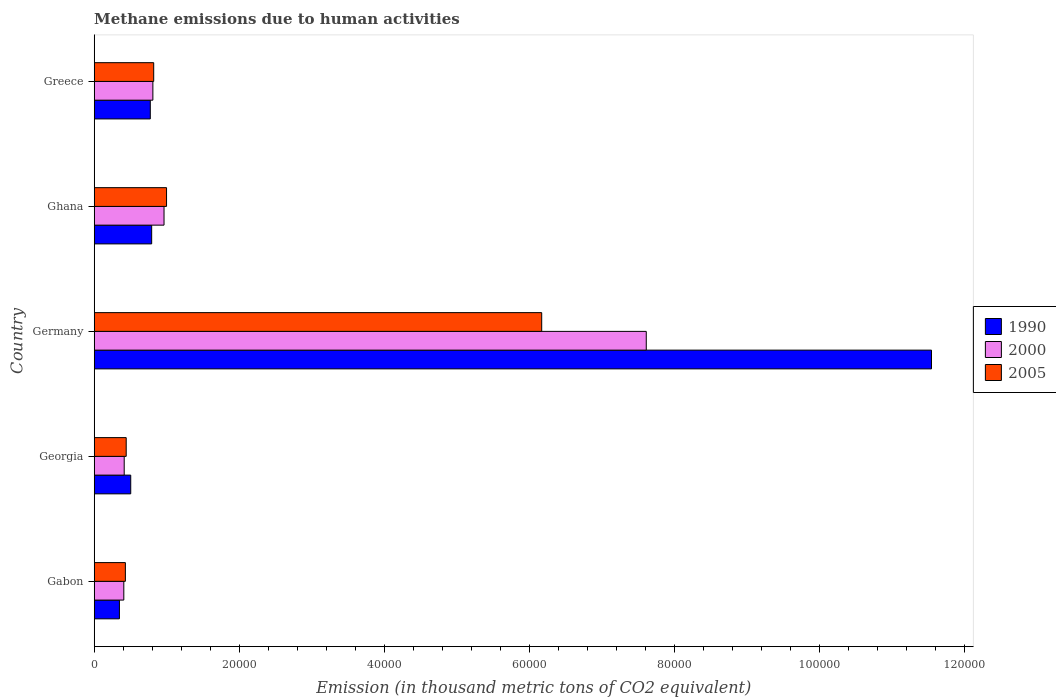How many different coloured bars are there?
Provide a succinct answer. 3. Are the number of bars per tick equal to the number of legend labels?
Keep it short and to the point. Yes. Are the number of bars on each tick of the Y-axis equal?
Provide a short and direct response. Yes. What is the label of the 4th group of bars from the top?
Make the answer very short. Georgia. What is the amount of methane emitted in 1990 in Greece?
Provide a short and direct response. 7734.1. Across all countries, what is the maximum amount of methane emitted in 1990?
Your response must be concise. 1.15e+05. Across all countries, what is the minimum amount of methane emitted in 2000?
Your answer should be very brief. 4082.1. In which country was the amount of methane emitted in 2005 minimum?
Keep it short and to the point. Gabon. What is the total amount of methane emitted in 2005 in the graph?
Your response must be concise. 8.86e+04. What is the difference between the amount of methane emitted in 1990 in Gabon and that in Ghana?
Give a very brief answer. -4446.2. What is the difference between the amount of methane emitted in 2000 in Ghana and the amount of methane emitted in 2005 in Georgia?
Your answer should be very brief. 5214.7. What is the average amount of methane emitted in 1990 per country?
Provide a short and direct response. 2.79e+04. What is the difference between the amount of methane emitted in 1990 and amount of methane emitted in 2000 in Greece?
Offer a very short reply. -355.1. What is the ratio of the amount of methane emitted in 2000 in Gabon to that in Ghana?
Ensure brevity in your answer.  0.42. Is the amount of methane emitted in 1990 in Gabon less than that in Ghana?
Offer a terse response. Yes. Is the difference between the amount of methane emitted in 1990 in Germany and Ghana greater than the difference between the amount of methane emitted in 2000 in Germany and Ghana?
Give a very brief answer. Yes. What is the difference between the highest and the second highest amount of methane emitted in 2000?
Provide a succinct answer. 6.65e+04. What is the difference between the highest and the lowest amount of methane emitted in 1990?
Ensure brevity in your answer.  1.12e+05. What does the 2nd bar from the top in Germany represents?
Offer a terse response. 2000. How many countries are there in the graph?
Provide a succinct answer. 5. What is the difference between two consecutive major ticks on the X-axis?
Keep it short and to the point. 2.00e+04. Are the values on the major ticks of X-axis written in scientific E-notation?
Make the answer very short. No. Does the graph contain any zero values?
Keep it short and to the point. No. What is the title of the graph?
Give a very brief answer. Methane emissions due to human activities. What is the label or title of the X-axis?
Offer a very short reply. Emission (in thousand metric tons of CO2 equivalent). What is the Emission (in thousand metric tons of CO2 equivalent) of 1990 in Gabon?
Offer a terse response. 3478.5. What is the Emission (in thousand metric tons of CO2 equivalent) of 2000 in Gabon?
Your response must be concise. 4082.1. What is the Emission (in thousand metric tons of CO2 equivalent) in 2005 in Gabon?
Provide a succinct answer. 4298.1. What is the Emission (in thousand metric tons of CO2 equivalent) of 1990 in Georgia?
Give a very brief answer. 5037. What is the Emission (in thousand metric tons of CO2 equivalent) of 2000 in Georgia?
Offer a very short reply. 4137.4. What is the Emission (in thousand metric tons of CO2 equivalent) of 2005 in Georgia?
Keep it short and to the point. 4413.2. What is the Emission (in thousand metric tons of CO2 equivalent) in 1990 in Germany?
Provide a short and direct response. 1.15e+05. What is the Emission (in thousand metric tons of CO2 equivalent) in 2000 in Germany?
Your response must be concise. 7.61e+04. What is the Emission (in thousand metric tons of CO2 equivalent) in 2005 in Germany?
Provide a succinct answer. 6.17e+04. What is the Emission (in thousand metric tons of CO2 equivalent) in 1990 in Ghana?
Your response must be concise. 7924.7. What is the Emission (in thousand metric tons of CO2 equivalent) of 2000 in Ghana?
Provide a short and direct response. 9627.9. What is the Emission (in thousand metric tons of CO2 equivalent) in 2005 in Ghana?
Provide a succinct answer. 9975.3. What is the Emission (in thousand metric tons of CO2 equivalent) of 1990 in Greece?
Make the answer very short. 7734.1. What is the Emission (in thousand metric tons of CO2 equivalent) in 2000 in Greece?
Ensure brevity in your answer.  8089.2. What is the Emission (in thousand metric tons of CO2 equivalent) of 2005 in Greece?
Your response must be concise. 8204.9. Across all countries, what is the maximum Emission (in thousand metric tons of CO2 equivalent) in 1990?
Provide a short and direct response. 1.15e+05. Across all countries, what is the maximum Emission (in thousand metric tons of CO2 equivalent) of 2000?
Your response must be concise. 7.61e+04. Across all countries, what is the maximum Emission (in thousand metric tons of CO2 equivalent) of 2005?
Offer a very short reply. 6.17e+04. Across all countries, what is the minimum Emission (in thousand metric tons of CO2 equivalent) in 1990?
Your answer should be very brief. 3478.5. Across all countries, what is the minimum Emission (in thousand metric tons of CO2 equivalent) of 2000?
Your response must be concise. 4082.1. Across all countries, what is the minimum Emission (in thousand metric tons of CO2 equivalent) in 2005?
Keep it short and to the point. 4298.1. What is the total Emission (in thousand metric tons of CO2 equivalent) of 1990 in the graph?
Offer a terse response. 1.40e+05. What is the total Emission (in thousand metric tons of CO2 equivalent) of 2000 in the graph?
Your response must be concise. 1.02e+05. What is the total Emission (in thousand metric tons of CO2 equivalent) of 2005 in the graph?
Give a very brief answer. 8.86e+04. What is the difference between the Emission (in thousand metric tons of CO2 equivalent) in 1990 in Gabon and that in Georgia?
Make the answer very short. -1558.5. What is the difference between the Emission (in thousand metric tons of CO2 equivalent) of 2000 in Gabon and that in Georgia?
Your answer should be very brief. -55.3. What is the difference between the Emission (in thousand metric tons of CO2 equivalent) in 2005 in Gabon and that in Georgia?
Give a very brief answer. -115.1. What is the difference between the Emission (in thousand metric tons of CO2 equivalent) in 1990 in Gabon and that in Germany?
Your answer should be very brief. -1.12e+05. What is the difference between the Emission (in thousand metric tons of CO2 equivalent) of 2000 in Gabon and that in Germany?
Your response must be concise. -7.20e+04. What is the difference between the Emission (in thousand metric tons of CO2 equivalent) of 2005 in Gabon and that in Germany?
Keep it short and to the point. -5.74e+04. What is the difference between the Emission (in thousand metric tons of CO2 equivalent) of 1990 in Gabon and that in Ghana?
Offer a terse response. -4446.2. What is the difference between the Emission (in thousand metric tons of CO2 equivalent) of 2000 in Gabon and that in Ghana?
Your answer should be very brief. -5545.8. What is the difference between the Emission (in thousand metric tons of CO2 equivalent) of 2005 in Gabon and that in Ghana?
Your answer should be very brief. -5677.2. What is the difference between the Emission (in thousand metric tons of CO2 equivalent) in 1990 in Gabon and that in Greece?
Your answer should be very brief. -4255.6. What is the difference between the Emission (in thousand metric tons of CO2 equivalent) of 2000 in Gabon and that in Greece?
Make the answer very short. -4007.1. What is the difference between the Emission (in thousand metric tons of CO2 equivalent) of 2005 in Gabon and that in Greece?
Provide a short and direct response. -3906.8. What is the difference between the Emission (in thousand metric tons of CO2 equivalent) of 1990 in Georgia and that in Germany?
Provide a short and direct response. -1.10e+05. What is the difference between the Emission (in thousand metric tons of CO2 equivalent) of 2000 in Georgia and that in Germany?
Offer a very short reply. -7.20e+04. What is the difference between the Emission (in thousand metric tons of CO2 equivalent) in 2005 in Georgia and that in Germany?
Your response must be concise. -5.73e+04. What is the difference between the Emission (in thousand metric tons of CO2 equivalent) in 1990 in Georgia and that in Ghana?
Your answer should be very brief. -2887.7. What is the difference between the Emission (in thousand metric tons of CO2 equivalent) in 2000 in Georgia and that in Ghana?
Provide a short and direct response. -5490.5. What is the difference between the Emission (in thousand metric tons of CO2 equivalent) of 2005 in Georgia and that in Ghana?
Your answer should be very brief. -5562.1. What is the difference between the Emission (in thousand metric tons of CO2 equivalent) of 1990 in Georgia and that in Greece?
Ensure brevity in your answer.  -2697.1. What is the difference between the Emission (in thousand metric tons of CO2 equivalent) in 2000 in Georgia and that in Greece?
Your response must be concise. -3951.8. What is the difference between the Emission (in thousand metric tons of CO2 equivalent) of 2005 in Georgia and that in Greece?
Your answer should be very brief. -3791.7. What is the difference between the Emission (in thousand metric tons of CO2 equivalent) of 1990 in Germany and that in Ghana?
Provide a short and direct response. 1.08e+05. What is the difference between the Emission (in thousand metric tons of CO2 equivalent) of 2000 in Germany and that in Ghana?
Your answer should be compact. 6.65e+04. What is the difference between the Emission (in thousand metric tons of CO2 equivalent) of 2005 in Germany and that in Ghana?
Your answer should be very brief. 5.17e+04. What is the difference between the Emission (in thousand metric tons of CO2 equivalent) in 1990 in Germany and that in Greece?
Your response must be concise. 1.08e+05. What is the difference between the Emission (in thousand metric tons of CO2 equivalent) in 2000 in Germany and that in Greece?
Ensure brevity in your answer.  6.80e+04. What is the difference between the Emission (in thousand metric tons of CO2 equivalent) in 2005 in Germany and that in Greece?
Provide a succinct answer. 5.35e+04. What is the difference between the Emission (in thousand metric tons of CO2 equivalent) of 1990 in Ghana and that in Greece?
Your answer should be compact. 190.6. What is the difference between the Emission (in thousand metric tons of CO2 equivalent) of 2000 in Ghana and that in Greece?
Offer a very short reply. 1538.7. What is the difference between the Emission (in thousand metric tons of CO2 equivalent) of 2005 in Ghana and that in Greece?
Give a very brief answer. 1770.4. What is the difference between the Emission (in thousand metric tons of CO2 equivalent) of 1990 in Gabon and the Emission (in thousand metric tons of CO2 equivalent) of 2000 in Georgia?
Make the answer very short. -658.9. What is the difference between the Emission (in thousand metric tons of CO2 equivalent) in 1990 in Gabon and the Emission (in thousand metric tons of CO2 equivalent) in 2005 in Georgia?
Make the answer very short. -934.7. What is the difference between the Emission (in thousand metric tons of CO2 equivalent) of 2000 in Gabon and the Emission (in thousand metric tons of CO2 equivalent) of 2005 in Georgia?
Your answer should be compact. -331.1. What is the difference between the Emission (in thousand metric tons of CO2 equivalent) in 1990 in Gabon and the Emission (in thousand metric tons of CO2 equivalent) in 2000 in Germany?
Ensure brevity in your answer.  -7.26e+04. What is the difference between the Emission (in thousand metric tons of CO2 equivalent) of 1990 in Gabon and the Emission (in thousand metric tons of CO2 equivalent) of 2005 in Germany?
Offer a very short reply. -5.82e+04. What is the difference between the Emission (in thousand metric tons of CO2 equivalent) in 2000 in Gabon and the Emission (in thousand metric tons of CO2 equivalent) in 2005 in Germany?
Offer a terse response. -5.76e+04. What is the difference between the Emission (in thousand metric tons of CO2 equivalent) in 1990 in Gabon and the Emission (in thousand metric tons of CO2 equivalent) in 2000 in Ghana?
Keep it short and to the point. -6149.4. What is the difference between the Emission (in thousand metric tons of CO2 equivalent) of 1990 in Gabon and the Emission (in thousand metric tons of CO2 equivalent) of 2005 in Ghana?
Give a very brief answer. -6496.8. What is the difference between the Emission (in thousand metric tons of CO2 equivalent) in 2000 in Gabon and the Emission (in thousand metric tons of CO2 equivalent) in 2005 in Ghana?
Your answer should be compact. -5893.2. What is the difference between the Emission (in thousand metric tons of CO2 equivalent) of 1990 in Gabon and the Emission (in thousand metric tons of CO2 equivalent) of 2000 in Greece?
Provide a short and direct response. -4610.7. What is the difference between the Emission (in thousand metric tons of CO2 equivalent) in 1990 in Gabon and the Emission (in thousand metric tons of CO2 equivalent) in 2005 in Greece?
Provide a short and direct response. -4726.4. What is the difference between the Emission (in thousand metric tons of CO2 equivalent) of 2000 in Gabon and the Emission (in thousand metric tons of CO2 equivalent) of 2005 in Greece?
Your answer should be compact. -4122.8. What is the difference between the Emission (in thousand metric tons of CO2 equivalent) of 1990 in Georgia and the Emission (in thousand metric tons of CO2 equivalent) of 2000 in Germany?
Offer a terse response. -7.11e+04. What is the difference between the Emission (in thousand metric tons of CO2 equivalent) in 1990 in Georgia and the Emission (in thousand metric tons of CO2 equivalent) in 2005 in Germany?
Offer a terse response. -5.67e+04. What is the difference between the Emission (in thousand metric tons of CO2 equivalent) in 2000 in Georgia and the Emission (in thousand metric tons of CO2 equivalent) in 2005 in Germany?
Your answer should be compact. -5.76e+04. What is the difference between the Emission (in thousand metric tons of CO2 equivalent) in 1990 in Georgia and the Emission (in thousand metric tons of CO2 equivalent) in 2000 in Ghana?
Give a very brief answer. -4590.9. What is the difference between the Emission (in thousand metric tons of CO2 equivalent) of 1990 in Georgia and the Emission (in thousand metric tons of CO2 equivalent) of 2005 in Ghana?
Your answer should be very brief. -4938.3. What is the difference between the Emission (in thousand metric tons of CO2 equivalent) of 2000 in Georgia and the Emission (in thousand metric tons of CO2 equivalent) of 2005 in Ghana?
Your answer should be compact. -5837.9. What is the difference between the Emission (in thousand metric tons of CO2 equivalent) in 1990 in Georgia and the Emission (in thousand metric tons of CO2 equivalent) in 2000 in Greece?
Your answer should be very brief. -3052.2. What is the difference between the Emission (in thousand metric tons of CO2 equivalent) in 1990 in Georgia and the Emission (in thousand metric tons of CO2 equivalent) in 2005 in Greece?
Your response must be concise. -3167.9. What is the difference between the Emission (in thousand metric tons of CO2 equivalent) in 2000 in Georgia and the Emission (in thousand metric tons of CO2 equivalent) in 2005 in Greece?
Ensure brevity in your answer.  -4067.5. What is the difference between the Emission (in thousand metric tons of CO2 equivalent) in 1990 in Germany and the Emission (in thousand metric tons of CO2 equivalent) in 2000 in Ghana?
Keep it short and to the point. 1.06e+05. What is the difference between the Emission (in thousand metric tons of CO2 equivalent) in 1990 in Germany and the Emission (in thousand metric tons of CO2 equivalent) in 2005 in Ghana?
Give a very brief answer. 1.05e+05. What is the difference between the Emission (in thousand metric tons of CO2 equivalent) in 2000 in Germany and the Emission (in thousand metric tons of CO2 equivalent) in 2005 in Ghana?
Offer a terse response. 6.61e+04. What is the difference between the Emission (in thousand metric tons of CO2 equivalent) in 1990 in Germany and the Emission (in thousand metric tons of CO2 equivalent) in 2000 in Greece?
Your answer should be very brief. 1.07e+05. What is the difference between the Emission (in thousand metric tons of CO2 equivalent) in 1990 in Germany and the Emission (in thousand metric tons of CO2 equivalent) in 2005 in Greece?
Your answer should be very brief. 1.07e+05. What is the difference between the Emission (in thousand metric tons of CO2 equivalent) in 2000 in Germany and the Emission (in thousand metric tons of CO2 equivalent) in 2005 in Greece?
Your answer should be compact. 6.79e+04. What is the difference between the Emission (in thousand metric tons of CO2 equivalent) of 1990 in Ghana and the Emission (in thousand metric tons of CO2 equivalent) of 2000 in Greece?
Give a very brief answer. -164.5. What is the difference between the Emission (in thousand metric tons of CO2 equivalent) of 1990 in Ghana and the Emission (in thousand metric tons of CO2 equivalent) of 2005 in Greece?
Offer a very short reply. -280.2. What is the difference between the Emission (in thousand metric tons of CO2 equivalent) in 2000 in Ghana and the Emission (in thousand metric tons of CO2 equivalent) in 2005 in Greece?
Your answer should be compact. 1423. What is the average Emission (in thousand metric tons of CO2 equivalent) in 1990 per country?
Give a very brief answer. 2.79e+04. What is the average Emission (in thousand metric tons of CO2 equivalent) in 2000 per country?
Keep it short and to the point. 2.04e+04. What is the average Emission (in thousand metric tons of CO2 equivalent) of 2005 per country?
Your answer should be compact. 1.77e+04. What is the difference between the Emission (in thousand metric tons of CO2 equivalent) in 1990 and Emission (in thousand metric tons of CO2 equivalent) in 2000 in Gabon?
Make the answer very short. -603.6. What is the difference between the Emission (in thousand metric tons of CO2 equivalent) of 1990 and Emission (in thousand metric tons of CO2 equivalent) of 2005 in Gabon?
Keep it short and to the point. -819.6. What is the difference between the Emission (in thousand metric tons of CO2 equivalent) in 2000 and Emission (in thousand metric tons of CO2 equivalent) in 2005 in Gabon?
Your answer should be very brief. -216. What is the difference between the Emission (in thousand metric tons of CO2 equivalent) in 1990 and Emission (in thousand metric tons of CO2 equivalent) in 2000 in Georgia?
Provide a short and direct response. 899.6. What is the difference between the Emission (in thousand metric tons of CO2 equivalent) in 1990 and Emission (in thousand metric tons of CO2 equivalent) in 2005 in Georgia?
Offer a very short reply. 623.8. What is the difference between the Emission (in thousand metric tons of CO2 equivalent) of 2000 and Emission (in thousand metric tons of CO2 equivalent) of 2005 in Georgia?
Provide a short and direct response. -275.8. What is the difference between the Emission (in thousand metric tons of CO2 equivalent) of 1990 and Emission (in thousand metric tons of CO2 equivalent) of 2000 in Germany?
Your answer should be very brief. 3.93e+04. What is the difference between the Emission (in thousand metric tons of CO2 equivalent) of 1990 and Emission (in thousand metric tons of CO2 equivalent) of 2005 in Germany?
Make the answer very short. 5.37e+04. What is the difference between the Emission (in thousand metric tons of CO2 equivalent) of 2000 and Emission (in thousand metric tons of CO2 equivalent) of 2005 in Germany?
Offer a very short reply. 1.44e+04. What is the difference between the Emission (in thousand metric tons of CO2 equivalent) of 1990 and Emission (in thousand metric tons of CO2 equivalent) of 2000 in Ghana?
Offer a terse response. -1703.2. What is the difference between the Emission (in thousand metric tons of CO2 equivalent) in 1990 and Emission (in thousand metric tons of CO2 equivalent) in 2005 in Ghana?
Provide a succinct answer. -2050.6. What is the difference between the Emission (in thousand metric tons of CO2 equivalent) of 2000 and Emission (in thousand metric tons of CO2 equivalent) of 2005 in Ghana?
Your answer should be compact. -347.4. What is the difference between the Emission (in thousand metric tons of CO2 equivalent) in 1990 and Emission (in thousand metric tons of CO2 equivalent) in 2000 in Greece?
Your response must be concise. -355.1. What is the difference between the Emission (in thousand metric tons of CO2 equivalent) of 1990 and Emission (in thousand metric tons of CO2 equivalent) of 2005 in Greece?
Provide a succinct answer. -470.8. What is the difference between the Emission (in thousand metric tons of CO2 equivalent) of 2000 and Emission (in thousand metric tons of CO2 equivalent) of 2005 in Greece?
Your response must be concise. -115.7. What is the ratio of the Emission (in thousand metric tons of CO2 equivalent) of 1990 in Gabon to that in Georgia?
Your answer should be compact. 0.69. What is the ratio of the Emission (in thousand metric tons of CO2 equivalent) in 2000 in Gabon to that in Georgia?
Your response must be concise. 0.99. What is the ratio of the Emission (in thousand metric tons of CO2 equivalent) in 2005 in Gabon to that in Georgia?
Provide a succinct answer. 0.97. What is the ratio of the Emission (in thousand metric tons of CO2 equivalent) of 1990 in Gabon to that in Germany?
Ensure brevity in your answer.  0.03. What is the ratio of the Emission (in thousand metric tons of CO2 equivalent) of 2000 in Gabon to that in Germany?
Provide a succinct answer. 0.05. What is the ratio of the Emission (in thousand metric tons of CO2 equivalent) in 2005 in Gabon to that in Germany?
Give a very brief answer. 0.07. What is the ratio of the Emission (in thousand metric tons of CO2 equivalent) in 1990 in Gabon to that in Ghana?
Ensure brevity in your answer.  0.44. What is the ratio of the Emission (in thousand metric tons of CO2 equivalent) of 2000 in Gabon to that in Ghana?
Your response must be concise. 0.42. What is the ratio of the Emission (in thousand metric tons of CO2 equivalent) in 2005 in Gabon to that in Ghana?
Your answer should be compact. 0.43. What is the ratio of the Emission (in thousand metric tons of CO2 equivalent) in 1990 in Gabon to that in Greece?
Provide a succinct answer. 0.45. What is the ratio of the Emission (in thousand metric tons of CO2 equivalent) in 2000 in Gabon to that in Greece?
Keep it short and to the point. 0.5. What is the ratio of the Emission (in thousand metric tons of CO2 equivalent) in 2005 in Gabon to that in Greece?
Offer a very short reply. 0.52. What is the ratio of the Emission (in thousand metric tons of CO2 equivalent) in 1990 in Georgia to that in Germany?
Provide a succinct answer. 0.04. What is the ratio of the Emission (in thousand metric tons of CO2 equivalent) in 2000 in Georgia to that in Germany?
Your answer should be compact. 0.05. What is the ratio of the Emission (in thousand metric tons of CO2 equivalent) in 2005 in Georgia to that in Germany?
Offer a very short reply. 0.07. What is the ratio of the Emission (in thousand metric tons of CO2 equivalent) of 1990 in Georgia to that in Ghana?
Offer a terse response. 0.64. What is the ratio of the Emission (in thousand metric tons of CO2 equivalent) in 2000 in Georgia to that in Ghana?
Provide a succinct answer. 0.43. What is the ratio of the Emission (in thousand metric tons of CO2 equivalent) in 2005 in Georgia to that in Ghana?
Offer a very short reply. 0.44. What is the ratio of the Emission (in thousand metric tons of CO2 equivalent) in 1990 in Georgia to that in Greece?
Provide a succinct answer. 0.65. What is the ratio of the Emission (in thousand metric tons of CO2 equivalent) of 2000 in Georgia to that in Greece?
Keep it short and to the point. 0.51. What is the ratio of the Emission (in thousand metric tons of CO2 equivalent) of 2005 in Georgia to that in Greece?
Your answer should be compact. 0.54. What is the ratio of the Emission (in thousand metric tons of CO2 equivalent) in 1990 in Germany to that in Ghana?
Offer a terse response. 14.57. What is the ratio of the Emission (in thousand metric tons of CO2 equivalent) in 2000 in Germany to that in Ghana?
Make the answer very short. 7.91. What is the ratio of the Emission (in thousand metric tons of CO2 equivalent) of 2005 in Germany to that in Ghana?
Your answer should be compact. 6.19. What is the ratio of the Emission (in thousand metric tons of CO2 equivalent) in 1990 in Germany to that in Greece?
Your response must be concise. 14.93. What is the ratio of the Emission (in thousand metric tons of CO2 equivalent) in 2000 in Germany to that in Greece?
Offer a very short reply. 9.41. What is the ratio of the Emission (in thousand metric tons of CO2 equivalent) of 2005 in Germany to that in Greece?
Give a very brief answer. 7.52. What is the ratio of the Emission (in thousand metric tons of CO2 equivalent) in 1990 in Ghana to that in Greece?
Provide a short and direct response. 1.02. What is the ratio of the Emission (in thousand metric tons of CO2 equivalent) of 2000 in Ghana to that in Greece?
Your response must be concise. 1.19. What is the ratio of the Emission (in thousand metric tons of CO2 equivalent) of 2005 in Ghana to that in Greece?
Offer a very short reply. 1.22. What is the difference between the highest and the second highest Emission (in thousand metric tons of CO2 equivalent) of 1990?
Keep it short and to the point. 1.08e+05. What is the difference between the highest and the second highest Emission (in thousand metric tons of CO2 equivalent) of 2000?
Provide a succinct answer. 6.65e+04. What is the difference between the highest and the second highest Emission (in thousand metric tons of CO2 equivalent) in 2005?
Your answer should be compact. 5.17e+04. What is the difference between the highest and the lowest Emission (in thousand metric tons of CO2 equivalent) of 1990?
Offer a very short reply. 1.12e+05. What is the difference between the highest and the lowest Emission (in thousand metric tons of CO2 equivalent) of 2000?
Your response must be concise. 7.20e+04. What is the difference between the highest and the lowest Emission (in thousand metric tons of CO2 equivalent) in 2005?
Ensure brevity in your answer.  5.74e+04. 